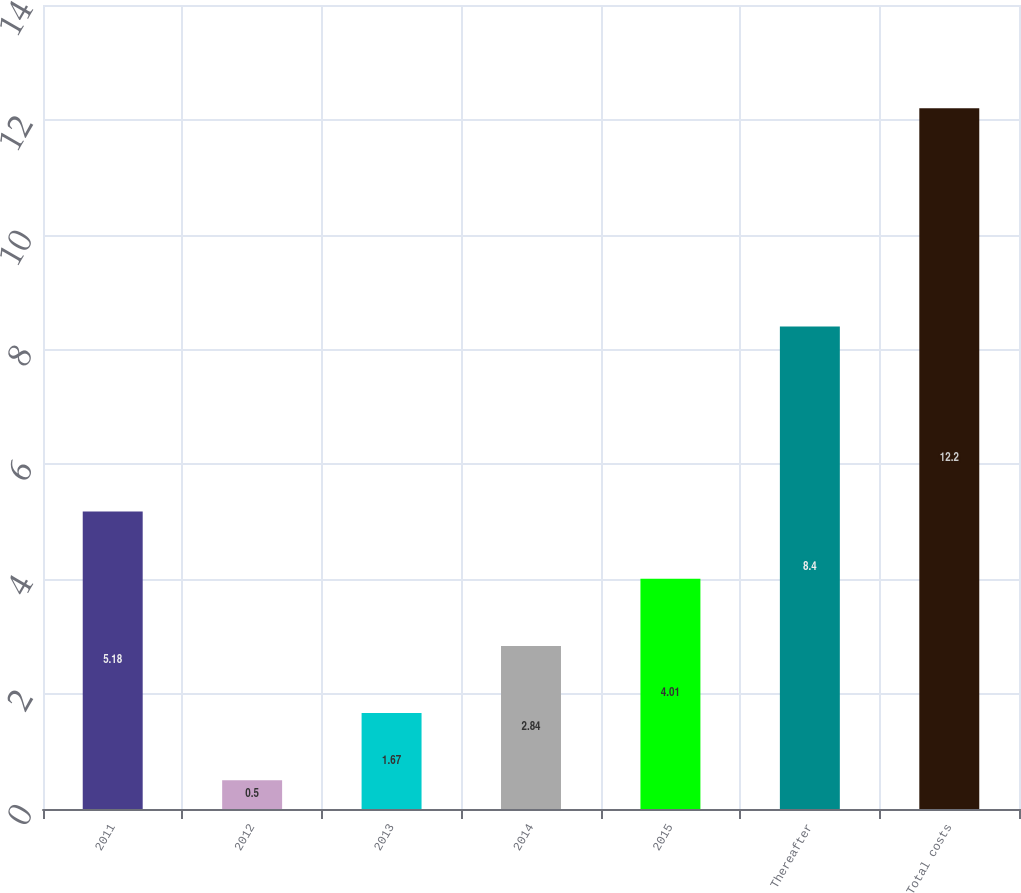Convert chart. <chart><loc_0><loc_0><loc_500><loc_500><bar_chart><fcel>2011<fcel>2012<fcel>2013<fcel>2014<fcel>2015<fcel>Thereafter<fcel>Total costs<nl><fcel>5.18<fcel>0.5<fcel>1.67<fcel>2.84<fcel>4.01<fcel>8.4<fcel>12.2<nl></chart> 